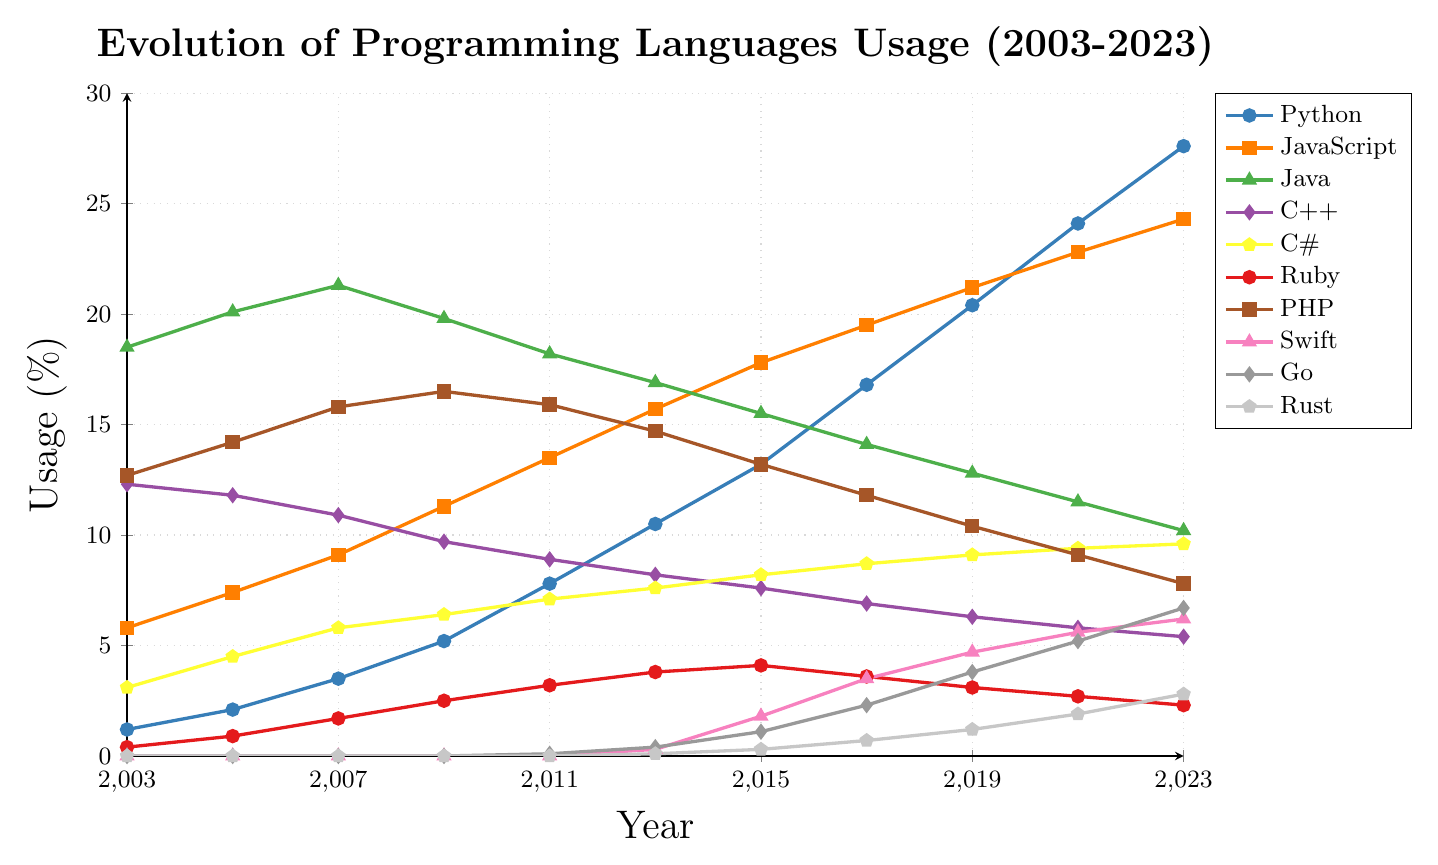What is the overall trend in the usage of Python from 2003 to 2023? By observing the graph, one can see that the line representing Python consistently increases from 1.2% in 2003 to 27.6% in 2023. This indicates a steady and significant rise in Python's usage over the two decades.
Answer: Steady increase Which language had the highest usage in 2003, and what was its usage percentage? From the figure, the language with the highest usage in 2003 is Java, with a usage percentage of 18.5%. This is evident from the highest point on the y-axis corresponding to the year 2003.
Answer: Java, 18.5% How has the usage of C++ changed from 2011 to 2023? The graph shows that the usage of C++ has been gradually decreasing from 8.9% in 2011 to 5.4% in 2023. This is clear from the descending trend line for C++ between these years.
Answer: Decreased Compare the usage trend of JavaScript and PHP from 2015 to 2023. The line for JavaScript shows an increasing trend from 17.8% in 2015 to 24.3% in 2023. In contrast, PHP shows a decreasing trend from 13.2% in 2015 to 7.8% in 2023. Visually, JavaScript's line goes upwards, while PHP's line goes downwards during the same period.
Answer: JavaScript increased, PHP decreased Which programming language shows the most rapid growth from 2013 onwards? Observing the graph from 2013, Python exhibits the most rapid growth, going from 10.5% in 2013 to 27.6% in 2023, which is a significant increase. The steepness of Python's line compared to other languages in this period illustrates this rapid growth.
Answer: Python Between Java and C# in 2023, which language has higher usage and by how much? In 2023, Java has a usage of 10.2%, while C# has a usage of 9.6%. By subtracting C#'s percentage from Java's, we get 10.2% - 9.6% = 0.6%. Therefore, Java's usage is higher than C#'s by 0.6%.
Answer: Java by 0.6% What's the average usage percentage of Rust over the periods shown in the graph? The usage percentages for Rust over the years are 0, 0, 0, 0, 0, 0.1, 0.3, 0.7, 1.2, 1.9, and 2.8. Summing these values gives 7.0. The total number of periods is 11. The average usage percentage is 7.0 / 11 ≈ 0.64%.
Answer: 0.64% What color represents the Ruby language in the graph? In the graph, the color that represents the Ruby language can be identified by looking at the legend. Ruby uses the color red.
Answer: Red 